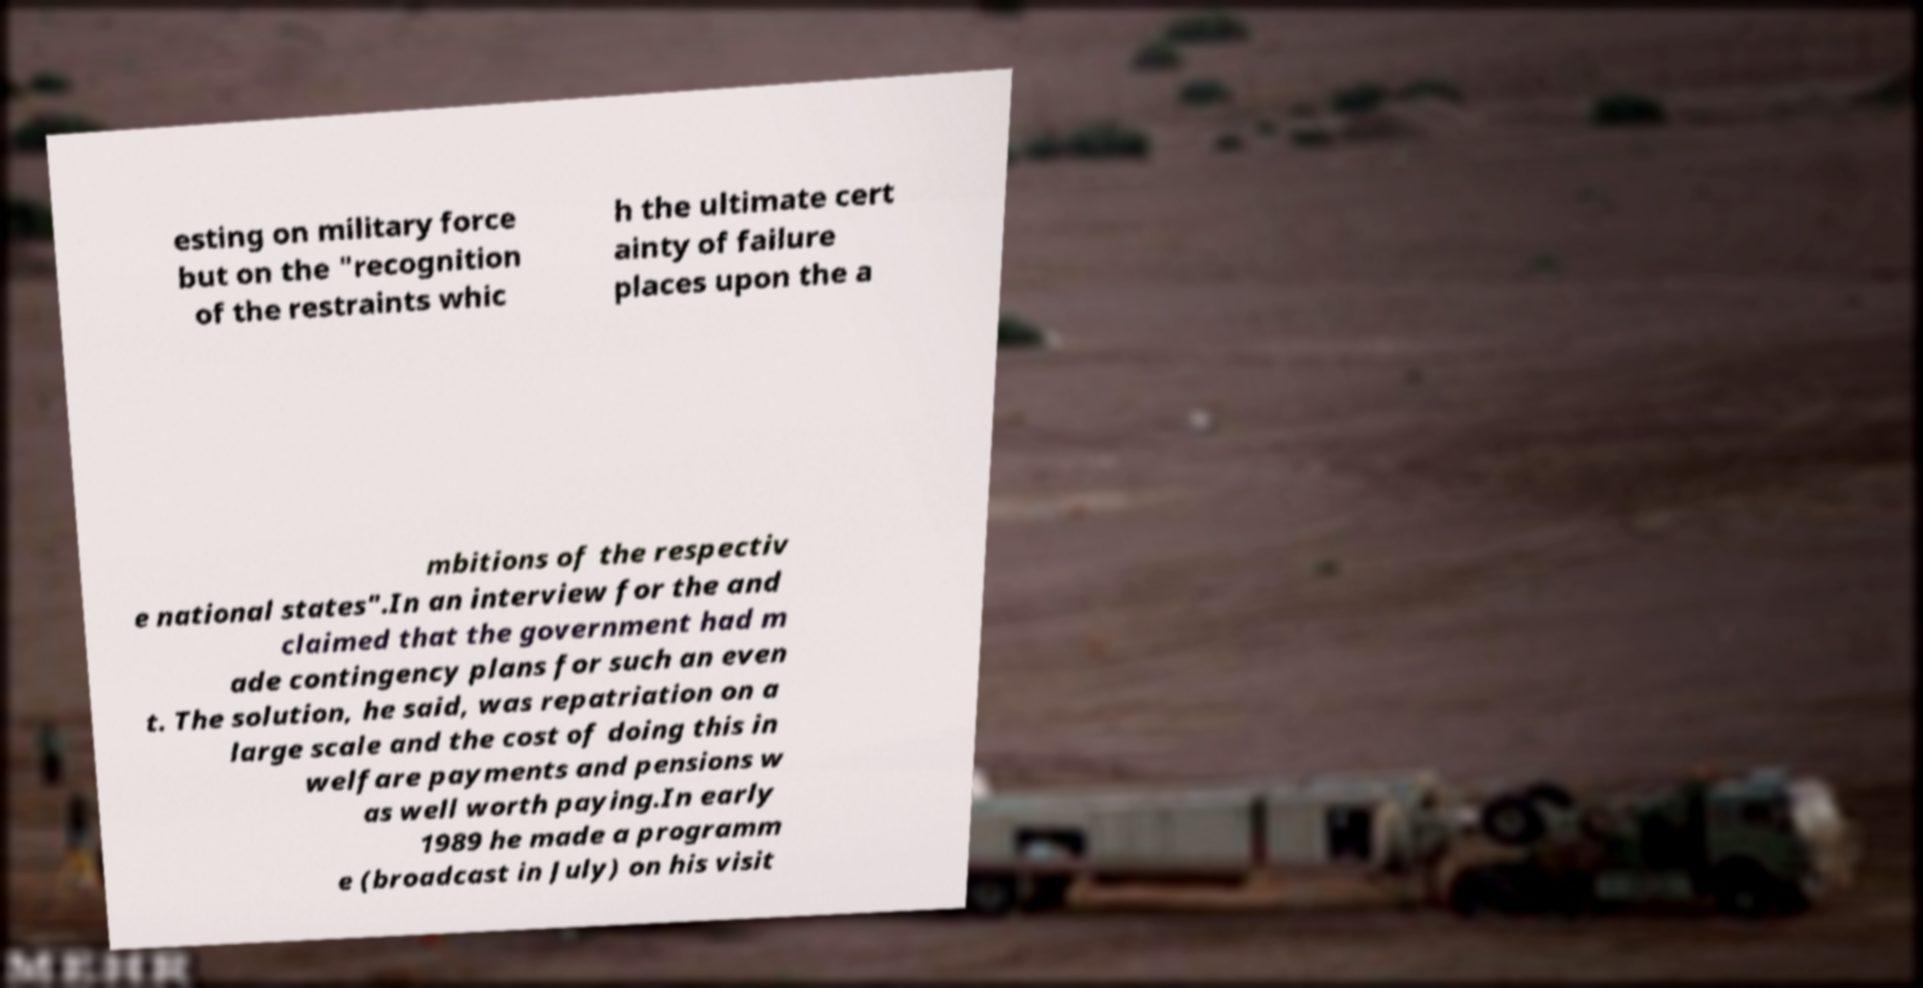Can you accurately transcribe the text from the provided image for me? esting on military force but on the "recognition of the restraints whic h the ultimate cert ainty of failure places upon the a mbitions of the respectiv e national states".In an interview for the and claimed that the government had m ade contingency plans for such an even t. The solution, he said, was repatriation on a large scale and the cost of doing this in welfare payments and pensions w as well worth paying.In early 1989 he made a programm e (broadcast in July) on his visit 